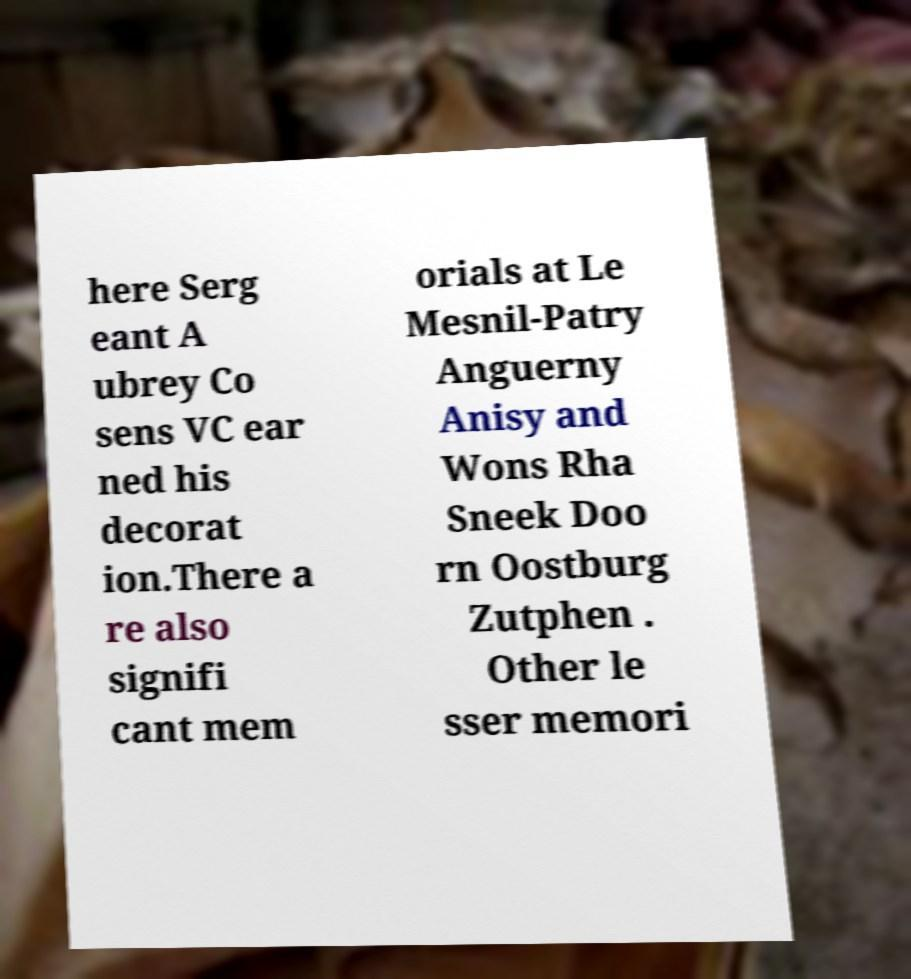Can you accurately transcribe the text from the provided image for me? here Serg eant A ubrey Co sens VC ear ned his decorat ion.There a re also signifi cant mem orials at Le Mesnil-Patry Anguerny Anisy and Wons Rha Sneek Doo rn Oostburg Zutphen . Other le sser memori 